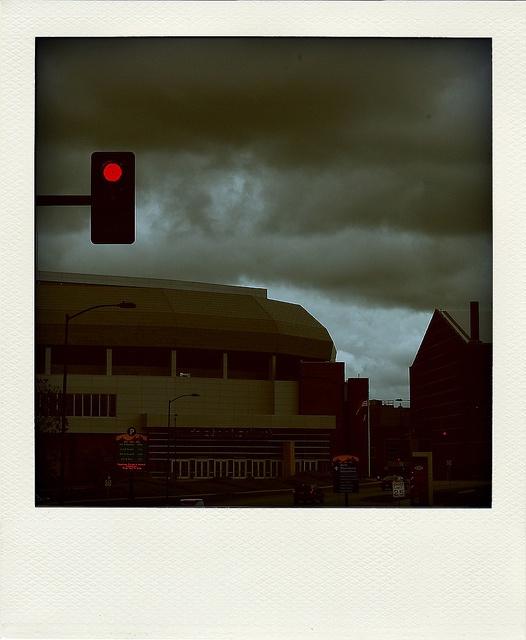Describe the objects in this image and their specific colors. I can see traffic light in lightgray, black, brown, and darkgreen tones and traffic light in lightgray, black, maroon, and red tones in this image. 